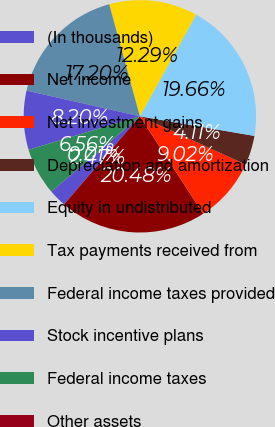<chart> <loc_0><loc_0><loc_500><loc_500><pie_chart><fcel>(In thousands)<fcel>Net income<fcel>Net investment gains<fcel>Depreciation and amortization<fcel>Equity in undistributed<fcel>Tax payments received from<fcel>Federal income taxes provided<fcel>Stock incentive plans<fcel>Federal income taxes<fcel>Other assets<nl><fcel>2.47%<fcel>20.48%<fcel>9.02%<fcel>4.11%<fcel>19.66%<fcel>12.29%<fcel>17.2%<fcel>8.2%<fcel>6.56%<fcel>0.01%<nl></chart> 